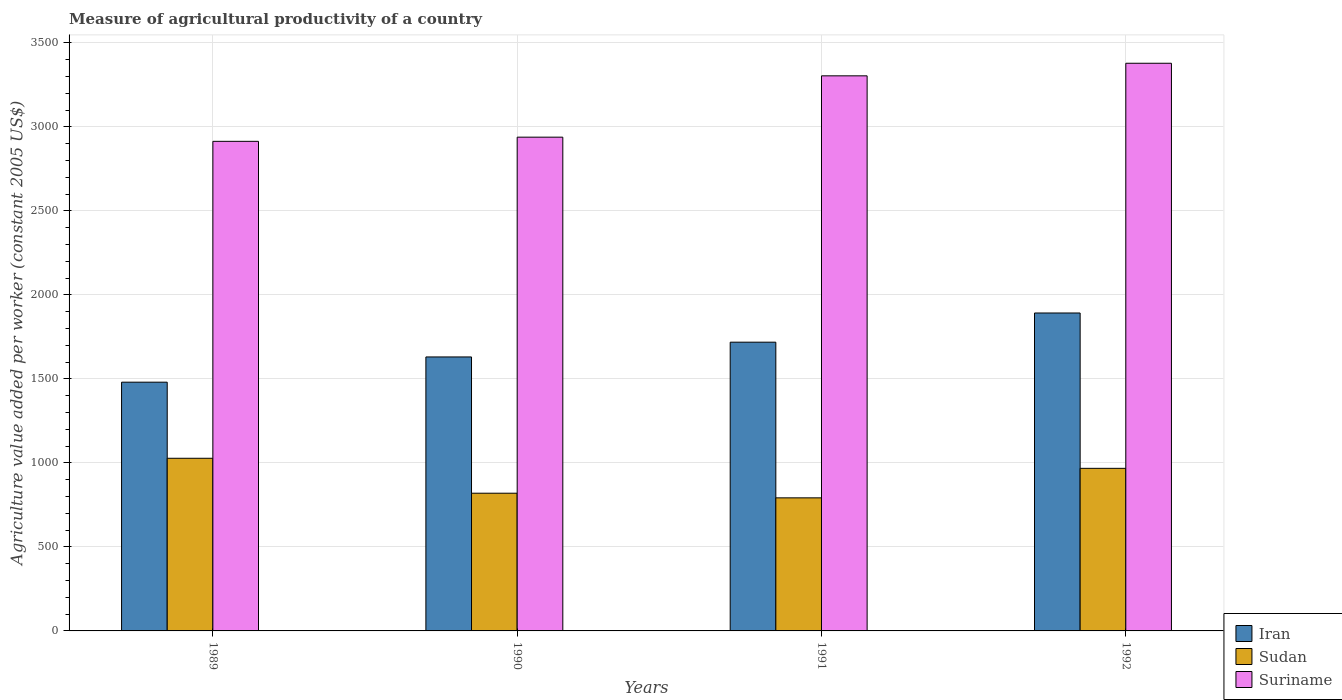In how many cases, is the number of bars for a given year not equal to the number of legend labels?
Provide a succinct answer. 0. What is the measure of agricultural productivity in Sudan in 1989?
Keep it short and to the point. 1027.74. Across all years, what is the maximum measure of agricultural productivity in Suriname?
Your response must be concise. 3379.21. Across all years, what is the minimum measure of agricultural productivity in Sudan?
Offer a very short reply. 792.17. What is the total measure of agricultural productivity in Iran in the graph?
Ensure brevity in your answer.  6723.04. What is the difference between the measure of agricultural productivity in Suriname in 1991 and that in 1992?
Your answer should be very brief. -74.89. What is the difference between the measure of agricultural productivity in Sudan in 1991 and the measure of agricultural productivity in Suriname in 1990?
Provide a succinct answer. -2147.09. What is the average measure of agricultural productivity in Iran per year?
Keep it short and to the point. 1680.76. In the year 1992, what is the difference between the measure of agricultural productivity in Suriname and measure of agricultural productivity in Iran?
Your answer should be compact. 1486.59. In how many years, is the measure of agricultural productivity in Sudan greater than 1400 US$?
Offer a very short reply. 0. What is the ratio of the measure of agricultural productivity in Suriname in 1990 to that in 1991?
Offer a terse response. 0.89. Is the measure of agricultural productivity in Suriname in 1989 less than that in 1992?
Keep it short and to the point. Yes. Is the difference between the measure of agricultural productivity in Suriname in 1989 and 1991 greater than the difference between the measure of agricultural productivity in Iran in 1989 and 1991?
Offer a very short reply. No. What is the difference between the highest and the second highest measure of agricultural productivity in Suriname?
Offer a very short reply. 74.89. What is the difference between the highest and the lowest measure of agricultural productivity in Sudan?
Give a very brief answer. 235.57. Is the sum of the measure of agricultural productivity in Suriname in 1989 and 1992 greater than the maximum measure of agricultural productivity in Iran across all years?
Ensure brevity in your answer.  Yes. What does the 1st bar from the left in 1990 represents?
Offer a very short reply. Iran. What does the 1st bar from the right in 1990 represents?
Give a very brief answer. Suriname. How many bars are there?
Give a very brief answer. 12. How many years are there in the graph?
Give a very brief answer. 4. Does the graph contain any zero values?
Your answer should be very brief. No. How many legend labels are there?
Keep it short and to the point. 3. What is the title of the graph?
Make the answer very short. Measure of agricultural productivity of a country. Does "Bolivia" appear as one of the legend labels in the graph?
Provide a short and direct response. No. What is the label or title of the X-axis?
Give a very brief answer. Years. What is the label or title of the Y-axis?
Provide a short and direct response. Agriculture value added per worker (constant 2005 US$). What is the Agriculture value added per worker (constant 2005 US$) in Iran in 1989?
Make the answer very short. 1480.68. What is the Agriculture value added per worker (constant 2005 US$) of Sudan in 1989?
Give a very brief answer. 1027.74. What is the Agriculture value added per worker (constant 2005 US$) in Suriname in 1989?
Make the answer very short. 2914.42. What is the Agriculture value added per worker (constant 2005 US$) of Iran in 1990?
Your response must be concise. 1630.93. What is the Agriculture value added per worker (constant 2005 US$) in Sudan in 1990?
Your answer should be compact. 819.79. What is the Agriculture value added per worker (constant 2005 US$) of Suriname in 1990?
Provide a succinct answer. 2939.26. What is the Agriculture value added per worker (constant 2005 US$) of Iran in 1991?
Your answer should be compact. 1718.82. What is the Agriculture value added per worker (constant 2005 US$) in Sudan in 1991?
Keep it short and to the point. 792.17. What is the Agriculture value added per worker (constant 2005 US$) of Suriname in 1991?
Offer a terse response. 3304.32. What is the Agriculture value added per worker (constant 2005 US$) in Iran in 1992?
Make the answer very short. 1892.62. What is the Agriculture value added per worker (constant 2005 US$) in Sudan in 1992?
Offer a terse response. 967.88. What is the Agriculture value added per worker (constant 2005 US$) of Suriname in 1992?
Give a very brief answer. 3379.21. Across all years, what is the maximum Agriculture value added per worker (constant 2005 US$) of Iran?
Provide a short and direct response. 1892.62. Across all years, what is the maximum Agriculture value added per worker (constant 2005 US$) in Sudan?
Your answer should be compact. 1027.74. Across all years, what is the maximum Agriculture value added per worker (constant 2005 US$) of Suriname?
Offer a terse response. 3379.21. Across all years, what is the minimum Agriculture value added per worker (constant 2005 US$) in Iran?
Offer a terse response. 1480.68. Across all years, what is the minimum Agriculture value added per worker (constant 2005 US$) in Sudan?
Keep it short and to the point. 792.17. Across all years, what is the minimum Agriculture value added per worker (constant 2005 US$) in Suriname?
Your response must be concise. 2914.42. What is the total Agriculture value added per worker (constant 2005 US$) of Iran in the graph?
Your response must be concise. 6723.04. What is the total Agriculture value added per worker (constant 2005 US$) of Sudan in the graph?
Your response must be concise. 3607.57. What is the total Agriculture value added per worker (constant 2005 US$) in Suriname in the graph?
Provide a succinct answer. 1.25e+04. What is the difference between the Agriculture value added per worker (constant 2005 US$) in Iran in 1989 and that in 1990?
Offer a very short reply. -150.25. What is the difference between the Agriculture value added per worker (constant 2005 US$) of Sudan in 1989 and that in 1990?
Give a very brief answer. 207.95. What is the difference between the Agriculture value added per worker (constant 2005 US$) of Suriname in 1989 and that in 1990?
Offer a terse response. -24.83. What is the difference between the Agriculture value added per worker (constant 2005 US$) in Iran in 1989 and that in 1991?
Your response must be concise. -238.14. What is the difference between the Agriculture value added per worker (constant 2005 US$) in Sudan in 1989 and that in 1991?
Give a very brief answer. 235.57. What is the difference between the Agriculture value added per worker (constant 2005 US$) of Suriname in 1989 and that in 1991?
Offer a terse response. -389.9. What is the difference between the Agriculture value added per worker (constant 2005 US$) in Iran in 1989 and that in 1992?
Provide a succinct answer. -411.94. What is the difference between the Agriculture value added per worker (constant 2005 US$) of Sudan in 1989 and that in 1992?
Give a very brief answer. 59.85. What is the difference between the Agriculture value added per worker (constant 2005 US$) in Suriname in 1989 and that in 1992?
Offer a terse response. -464.79. What is the difference between the Agriculture value added per worker (constant 2005 US$) of Iran in 1990 and that in 1991?
Ensure brevity in your answer.  -87.89. What is the difference between the Agriculture value added per worker (constant 2005 US$) in Sudan in 1990 and that in 1991?
Make the answer very short. 27.62. What is the difference between the Agriculture value added per worker (constant 2005 US$) of Suriname in 1990 and that in 1991?
Keep it short and to the point. -365.07. What is the difference between the Agriculture value added per worker (constant 2005 US$) in Iran in 1990 and that in 1992?
Your answer should be very brief. -261.69. What is the difference between the Agriculture value added per worker (constant 2005 US$) of Sudan in 1990 and that in 1992?
Give a very brief answer. -148.1. What is the difference between the Agriculture value added per worker (constant 2005 US$) in Suriname in 1990 and that in 1992?
Provide a succinct answer. -439.95. What is the difference between the Agriculture value added per worker (constant 2005 US$) in Iran in 1991 and that in 1992?
Provide a short and direct response. -173.8. What is the difference between the Agriculture value added per worker (constant 2005 US$) in Sudan in 1991 and that in 1992?
Offer a very short reply. -175.72. What is the difference between the Agriculture value added per worker (constant 2005 US$) in Suriname in 1991 and that in 1992?
Keep it short and to the point. -74.89. What is the difference between the Agriculture value added per worker (constant 2005 US$) of Iran in 1989 and the Agriculture value added per worker (constant 2005 US$) of Sudan in 1990?
Give a very brief answer. 660.89. What is the difference between the Agriculture value added per worker (constant 2005 US$) of Iran in 1989 and the Agriculture value added per worker (constant 2005 US$) of Suriname in 1990?
Provide a succinct answer. -1458.58. What is the difference between the Agriculture value added per worker (constant 2005 US$) of Sudan in 1989 and the Agriculture value added per worker (constant 2005 US$) of Suriname in 1990?
Offer a terse response. -1911.52. What is the difference between the Agriculture value added per worker (constant 2005 US$) of Iran in 1989 and the Agriculture value added per worker (constant 2005 US$) of Sudan in 1991?
Give a very brief answer. 688.51. What is the difference between the Agriculture value added per worker (constant 2005 US$) of Iran in 1989 and the Agriculture value added per worker (constant 2005 US$) of Suriname in 1991?
Offer a very short reply. -1823.65. What is the difference between the Agriculture value added per worker (constant 2005 US$) in Sudan in 1989 and the Agriculture value added per worker (constant 2005 US$) in Suriname in 1991?
Make the answer very short. -2276.59. What is the difference between the Agriculture value added per worker (constant 2005 US$) of Iran in 1989 and the Agriculture value added per worker (constant 2005 US$) of Sudan in 1992?
Provide a short and direct response. 512.79. What is the difference between the Agriculture value added per worker (constant 2005 US$) in Iran in 1989 and the Agriculture value added per worker (constant 2005 US$) in Suriname in 1992?
Ensure brevity in your answer.  -1898.53. What is the difference between the Agriculture value added per worker (constant 2005 US$) in Sudan in 1989 and the Agriculture value added per worker (constant 2005 US$) in Suriname in 1992?
Your response must be concise. -2351.47. What is the difference between the Agriculture value added per worker (constant 2005 US$) in Iran in 1990 and the Agriculture value added per worker (constant 2005 US$) in Sudan in 1991?
Your answer should be very brief. 838.76. What is the difference between the Agriculture value added per worker (constant 2005 US$) of Iran in 1990 and the Agriculture value added per worker (constant 2005 US$) of Suriname in 1991?
Your answer should be compact. -1673.39. What is the difference between the Agriculture value added per worker (constant 2005 US$) of Sudan in 1990 and the Agriculture value added per worker (constant 2005 US$) of Suriname in 1991?
Keep it short and to the point. -2484.54. What is the difference between the Agriculture value added per worker (constant 2005 US$) of Iran in 1990 and the Agriculture value added per worker (constant 2005 US$) of Sudan in 1992?
Make the answer very short. 663.05. What is the difference between the Agriculture value added per worker (constant 2005 US$) of Iran in 1990 and the Agriculture value added per worker (constant 2005 US$) of Suriname in 1992?
Give a very brief answer. -1748.28. What is the difference between the Agriculture value added per worker (constant 2005 US$) of Sudan in 1990 and the Agriculture value added per worker (constant 2005 US$) of Suriname in 1992?
Offer a terse response. -2559.42. What is the difference between the Agriculture value added per worker (constant 2005 US$) of Iran in 1991 and the Agriculture value added per worker (constant 2005 US$) of Sudan in 1992?
Offer a terse response. 750.94. What is the difference between the Agriculture value added per worker (constant 2005 US$) of Iran in 1991 and the Agriculture value added per worker (constant 2005 US$) of Suriname in 1992?
Ensure brevity in your answer.  -1660.39. What is the difference between the Agriculture value added per worker (constant 2005 US$) in Sudan in 1991 and the Agriculture value added per worker (constant 2005 US$) in Suriname in 1992?
Your answer should be compact. -2587.04. What is the average Agriculture value added per worker (constant 2005 US$) of Iran per year?
Give a very brief answer. 1680.76. What is the average Agriculture value added per worker (constant 2005 US$) of Sudan per year?
Make the answer very short. 901.89. What is the average Agriculture value added per worker (constant 2005 US$) in Suriname per year?
Your response must be concise. 3134.3. In the year 1989, what is the difference between the Agriculture value added per worker (constant 2005 US$) of Iran and Agriculture value added per worker (constant 2005 US$) of Sudan?
Ensure brevity in your answer.  452.94. In the year 1989, what is the difference between the Agriculture value added per worker (constant 2005 US$) of Iran and Agriculture value added per worker (constant 2005 US$) of Suriname?
Ensure brevity in your answer.  -1433.75. In the year 1989, what is the difference between the Agriculture value added per worker (constant 2005 US$) of Sudan and Agriculture value added per worker (constant 2005 US$) of Suriname?
Your response must be concise. -1886.69. In the year 1990, what is the difference between the Agriculture value added per worker (constant 2005 US$) in Iran and Agriculture value added per worker (constant 2005 US$) in Sudan?
Keep it short and to the point. 811.14. In the year 1990, what is the difference between the Agriculture value added per worker (constant 2005 US$) in Iran and Agriculture value added per worker (constant 2005 US$) in Suriname?
Make the answer very short. -1308.33. In the year 1990, what is the difference between the Agriculture value added per worker (constant 2005 US$) of Sudan and Agriculture value added per worker (constant 2005 US$) of Suriname?
Ensure brevity in your answer.  -2119.47. In the year 1991, what is the difference between the Agriculture value added per worker (constant 2005 US$) in Iran and Agriculture value added per worker (constant 2005 US$) in Sudan?
Make the answer very short. 926.65. In the year 1991, what is the difference between the Agriculture value added per worker (constant 2005 US$) in Iran and Agriculture value added per worker (constant 2005 US$) in Suriname?
Keep it short and to the point. -1585.5. In the year 1991, what is the difference between the Agriculture value added per worker (constant 2005 US$) in Sudan and Agriculture value added per worker (constant 2005 US$) in Suriname?
Ensure brevity in your answer.  -2512.16. In the year 1992, what is the difference between the Agriculture value added per worker (constant 2005 US$) in Iran and Agriculture value added per worker (constant 2005 US$) in Sudan?
Make the answer very short. 924.73. In the year 1992, what is the difference between the Agriculture value added per worker (constant 2005 US$) in Iran and Agriculture value added per worker (constant 2005 US$) in Suriname?
Make the answer very short. -1486.59. In the year 1992, what is the difference between the Agriculture value added per worker (constant 2005 US$) of Sudan and Agriculture value added per worker (constant 2005 US$) of Suriname?
Give a very brief answer. -2411.33. What is the ratio of the Agriculture value added per worker (constant 2005 US$) in Iran in 1989 to that in 1990?
Offer a very short reply. 0.91. What is the ratio of the Agriculture value added per worker (constant 2005 US$) of Sudan in 1989 to that in 1990?
Ensure brevity in your answer.  1.25. What is the ratio of the Agriculture value added per worker (constant 2005 US$) of Iran in 1989 to that in 1991?
Keep it short and to the point. 0.86. What is the ratio of the Agriculture value added per worker (constant 2005 US$) of Sudan in 1989 to that in 1991?
Offer a very short reply. 1.3. What is the ratio of the Agriculture value added per worker (constant 2005 US$) of Suriname in 1989 to that in 1991?
Give a very brief answer. 0.88. What is the ratio of the Agriculture value added per worker (constant 2005 US$) of Iran in 1989 to that in 1992?
Ensure brevity in your answer.  0.78. What is the ratio of the Agriculture value added per worker (constant 2005 US$) in Sudan in 1989 to that in 1992?
Give a very brief answer. 1.06. What is the ratio of the Agriculture value added per worker (constant 2005 US$) of Suriname in 1989 to that in 1992?
Your answer should be compact. 0.86. What is the ratio of the Agriculture value added per worker (constant 2005 US$) of Iran in 1990 to that in 1991?
Offer a terse response. 0.95. What is the ratio of the Agriculture value added per worker (constant 2005 US$) of Sudan in 1990 to that in 1991?
Keep it short and to the point. 1.03. What is the ratio of the Agriculture value added per worker (constant 2005 US$) of Suriname in 1990 to that in 1991?
Ensure brevity in your answer.  0.89. What is the ratio of the Agriculture value added per worker (constant 2005 US$) in Iran in 1990 to that in 1992?
Keep it short and to the point. 0.86. What is the ratio of the Agriculture value added per worker (constant 2005 US$) of Sudan in 1990 to that in 1992?
Give a very brief answer. 0.85. What is the ratio of the Agriculture value added per worker (constant 2005 US$) of Suriname in 1990 to that in 1992?
Make the answer very short. 0.87. What is the ratio of the Agriculture value added per worker (constant 2005 US$) of Iran in 1991 to that in 1992?
Provide a succinct answer. 0.91. What is the ratio of the Agriculture value added per worker (constant 2005 US$) of Sudan in 1991 to that in 1992?
Keep it short and to the point. 0.82. What is the ratio of the Agriculture value added per worker (constant 2005 US$) in Suriname in 1991 to that in 1992?
Give a very brief answer. 0.98. What is the difference between the highest and the second highest Agriculture value added per worker (constant 2005 US$) in Iran?
Offer a very short reply. 173.8. What is the difference between the highest and the second highest Agriculture value added per worker (constant 2005 US$) in Sudan?
Provide a short and direct response. 59.85. What is the difference between the highest and the second highest Agriculture value added per worker (constant 2005 US$) in Suriname?
Your response must be concise. 74.89. What is the difference between the highest and the lowest Agriculture value added per worker (constant 2005 US$) in Iran?
Offer a very short reply. 411.94. What is the difference between the highest and the lowest Agriculture value added per worker (constant 2005 US$) in Sudan?
Your response must be concise. 235.57. What is the difference between the highest and the lowest Agriculture value added per worker (constant 2005 US$) in Suriname?
Keep it short and to the point. 464.79. 